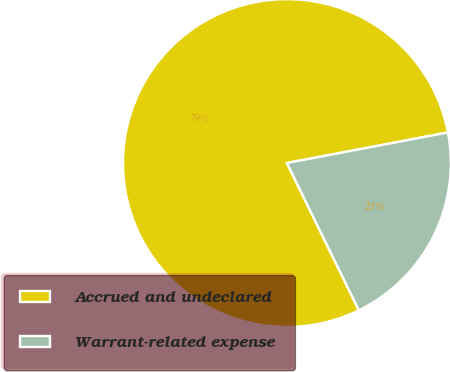Convert chart. <chart><loc_0><loc_0><loc_500><loc_500><pie_chart><fcel>Accrued and undeclared<fcel>Warrant-related expense<nl><fcel>79.25%<fcel>20.75%<nl></chart> 